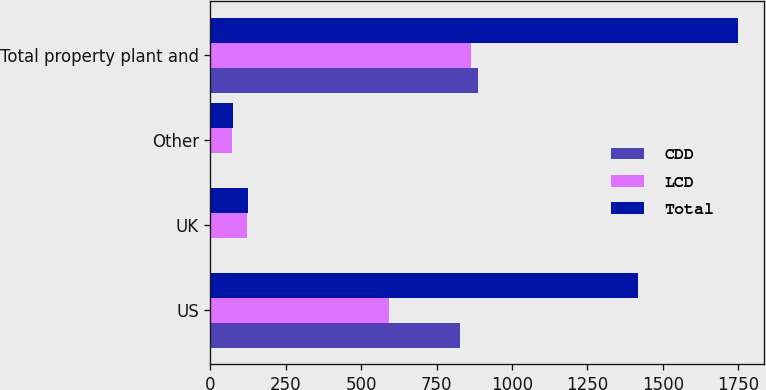Convert chart to OTSL. <chart><loc_0><loc_0><loc_500><loc_500><stacked_bar_chart><ecel><fcel>US<fcel>UK<fcel>Other<fcel>Total property plant and<nl><fcel>CDD<fcel>826.2<fcel>2.1<fcel>3<fcel>885.9<nl><fcel>LCD<fcel>590.6<fcel>120.7<fcel>70.3<fcel>863<nl><fcel>Total<fcel>1416.8<fcel>122.8<fcel>73.3<fcel>1748.9<nl></chart> 